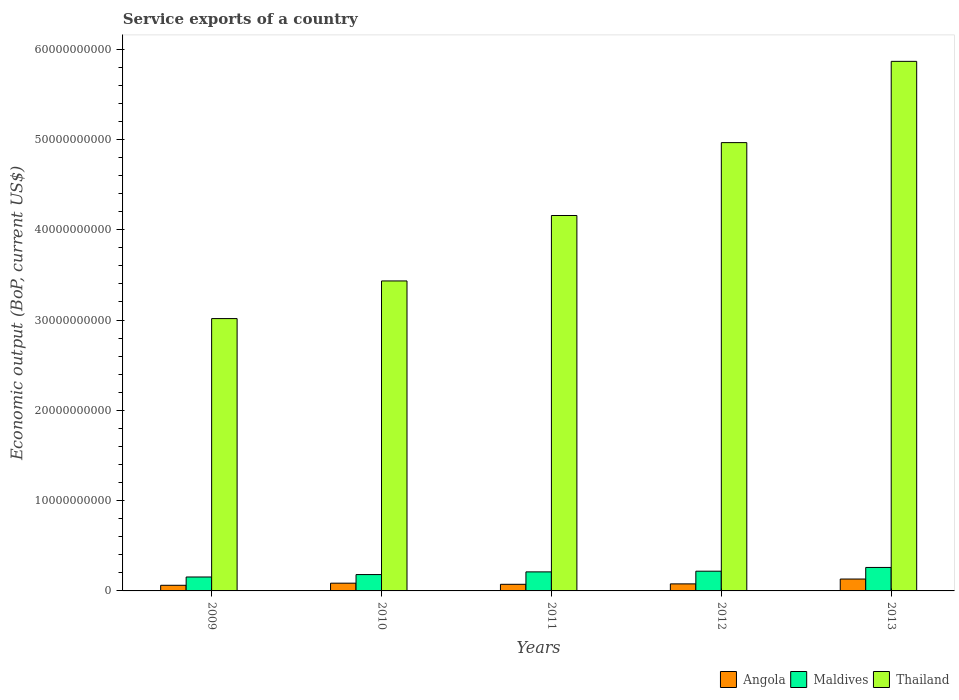How many bars are there on the 1st tick from the left?
Make the answer very short. 3. How many bars are there on the 4th tick from the right?
Offer a terse response. 3. In how many cases, is the number of bars for a given year not equal to the number of legend labels?
Your answer should be very brief. 0. What is the service exports in Angola in 2012?
Give a very brief answer. 7.80e+08. Across all years, what is the maximum service exports in Thailand?
Ensure brevity in your answer.  5.86e+1. Across all years, what is the minimum service exports in Maldives?
Provide a succinct answer. 1.54e+09. In which year was the service exports in Thailand minimum?
Your response must be concise. 2009. What is the total service exports in Maldives in the graph?
Keep it short and to the point. 1.02e+1. What is the difference between the service exports in Maldives in 2012 and that in 2013?
Offer a very short reply. -4.15e+08. What is the difference between the service exports in Maldives in 2010 and the service exports in Thailand in 2009?
Keep it short and to the point. -2.83e+1. What is the average service exports in Angola per year?
Ensure brevity in your answer.  8.62e+08. In the year 2013, what is the difference between the service exports in Maldives and service exports in Thailand?
Make the answer very short. -5.60e+1. What is the ratio of the service exports in Thailand in 2010 to that in 2011?
Offer a terse response. 0.83. What is the difference between the highest and the second highest service exports in Thailand?
Ensure brevity in your answer.  9.00e+09. What is the difference between the highest and the lowest service exports in Maldives?
Give a very brief answer. 1.06e+09. In how many years, is the service exports in Thailand greater than the average service exports in Thailand taken over all years?
Offer a very short reply. 2. What does the 1st bar from the left in 2011 represents?
Offer a very short reply. Angola. What does the 2nd bar from the right in 2009 represents?
Make the answer very short. Maldives. Is it the case that in every year, the sum of the service exports in Maldives and service exports in Thailand is greater than the service exports in Angola?
Your answer should be compact. Yes. How many bars are there?
Provide a succinct answer. 15. What is the difference between two consecutive major ticks on the Y-axis?
Your response must be concise. 1.00e+1. Does the graph contain any zero values?
Your response must be concise. No. What is the title of the graph?
Make the answer very short. Service exports of a country. Does "Nepal" appear as one of the legend labels in the graph?
Offer a terse response. No. What is the label or title of the X-axis?
Provide a succinct answer. Years. What is the label or title of the Y-axis?
Offer a terse response. Economic output (BoP, current US$). What is the Economic output (BoP, current US$) of Angola in 2009?
Provide a succinct answer. 6.23e+08. What is the Economic output (BoP, current US$) of Maldives in 2009?
Your answer should be very brief. 1.54e+09. What is the Economic output (BoP, current US$) in Thailand in 2009?
Provide a succinct answer. 3.02e+1. What is the Economic output (BoP, current US$) of Angola in 2010?
Your response must be concise. 8.57e+08. What is the Economic output (BoP, current US$) of Maldives in 2010?
Your response must be concise. 1.81e+09. What is the Economic output (BoP, current US$) of Thailand in 2010?
Your answer should be compact. 3.43e+1. What is the Economic output (BoP, current US$) of Angola in 2011?
Keep it short and to the point. 7.32e+08. What is the Economic output (BoP, current US$) of Maldives in 2011?
Give a very brief answer. 2.11e+09. What is the Economic output (BoP, current US$) in Thailand in 2011?
Ensure brevity in your answer.  4.16e+1. What is the Economic output (BoP, current US$) in Angola in 2012?
Your response must be concise. 7.80e+08. What is the Economic output (BoP, current US$) in Maldives in 2012?
Offer a very short reply. 2.18e+09. What is the Economic output (BoP, current US$) of Thailand in 2012?
Provide a short and direct response. 4.96e+1. What is the Economic output (BoP, current US$) of Angola in 2013?
Give a very brief answer. 1.32e+09. What is the Economic output (BoP, current US$) of Maldives in 2013?
Make the answer very short. 2.60e+09. What is the Economic output (BoP, current US$) in Thailand in 2013?
Your response must be concise. 5.86e+1. Across all years, what is the maximum Economic output (BoP, current US$) of Angola?
Give a very brief answer. 1.32e+09. Across all years, what is the maximum Economic output (BoP, current US$) of Maldives?
Keep it short and to the point. 2.60e+09. Across all years, what is the maximum Economic output (BoP, current US$) of Thailand?
Keep it short and to the point. 5.86e+1. Across all years, what is the minimum Economic output (BoP, current US$) of Angola?
Your answer should be compact. 6.23e+08. Across all years, what is the minimum Economic output (BoP, current US$) in Maldives?
Your answer should be very brief. 1.54e+09. Across all years, what is the minimum Economic output (BoP, current US$) in Thailand?
Offer a very short reply. 3.02e+1. What is the total Economic output (BoP, current US$) in Angola in the graph?
Your answer should be compact. 4.31e+09. What is the total Economic output (BoP, current US$) of Maldives in the graph?
Offer a very short reply. 1.02e+1. What is the total Economic output (BoP, current US$) of Thailand in the graph?
Provide a succinct answer. 2.14e+11. What is the difference between the Economic output (BoP, current US$) in Angola in 2009 and that in 2010?
Offer a terse response. -2.34e+08. What is the difference between the Economic output (BoP, current US$) in Maldives in 2009 and that in 2010?
Your answer should be compact. -2.67e+08. What is the difference between the Economic output (BoP, current US$) in Thailand in 2009 and that in 2010?
Offer a terse response. -4.17e+09. What is the difference between the Economic output (BoP, current US$) of Angola in 2009 and that in 2011?
Make the answer very short. -1.09e+08. What is the difference between the Economic output (BoP, current US$) of Maldives in 2009 and that in 2011?
Your answer should be very brief. -5.65e+08. What is the difference between the Economic output (BoP, current US$) in Thailand in 2009 and that in 2011?
Provide a succinct answer. -1.14e+1. What is the difference between the Economic output (BoP, current US$) in Angola in 2009 and that in 2012?
Your answer should be very brief. -1.57e+08. What is the difference between the Economic output (BoP, current US$) of Maldives in 2009 and that in 2012?
Keep it short and to the point. -6.41e+08. What is the difference between the Economic output (BoP, current US$) of Thailand in 2009 and that in 2012?
Ensure brevity in your answer.  -1.95e+1. What is the difference between the Economic output (BoP, current US$) in Angola in 2009 and that in 2013?
Give a very brief answer. -6.93e+08. What is the difference between the Economic output (BoP, current US$) of Maldives in 2009 and that in 2013?
Provide a succinct answer. -1.06e+09. What is the difference between the Economic output (BoP, current US$) in Thailand in 2009 and that in 2013?
Ensure brevity in your answer.  -2.85e+1. What is the difference between the Economic output (BoP, current US$) in Angola in 2010 and that in 2011?
Keep it short and to the point. 1.25e+08. What is the difference between the Economic output (BoP, current US$) of Maldives in 2010 and that in 2011?
Offer a very short reply. -2.99e+08. What is the difference between the Economic output (BoP, current US$) of Thailand in 2010 and that in 2011?
Ensure brevity in your answer.  -7.25e+09. What is the difference between the Economic output (BoP, current US$) of Angola in 2010 and that in 2012?
Provide a short and direct response. 7.69e+07. What is the difference between the Economic output (BoP, current US$) of Maldives in 2010 and that in 2012?
Offer a very short reply. -3.74e+08. What is the difference between the Economic output (BoP, current US$) in Thailand in 2010 and that in 2012?
Give a very brief answer. -1.53e+1. What is the difference between the Economic output (BoP, current US$) of Angola in 2010 and that in 2013?
Your answer should be compact. -4.59e+08. What is the difference between the Economic output (BoP, current US$) of Maldives in 2010 and that in 2013?
Offer a terse response. -7.89e+08. What is the difference between the Economic output (BoP, current US$) of Thailand in 2010 and that in 2013?
Provide a succinct answer. -2.43e+1. What is the difference between the Economic output (BoP, current US$) in Angola in 2011 and that in 2012?
Offer a terse response. -4.78e+07. What is the difference between the Economic output (BoP, current US$) in Maldives in 2011 and that in 2012?
Your response must be concise. -7.55e+07. What is the difference between the Economic output (BoP, current US$) of Thailand in 2011 and that in 2012?
Make the answer very short. -8.07e+09. What is the difference between the Economic output (BoP, current US$) in Angola in 2011 and that in 2013?
Offer a terse response. -5.83e+08. What is the difference between the Economic output (BoP, current US$) of Maldives in 2011 and that in 2013?
Ensure brevity in your answer.  -4.90e+08. What is the difference between the Economic output (BoP, current US$) in Thailand in 2011 and that in 2013?
Offer a terse response. -1.71e+1. What is the difference between the Economic output (BoP, current US$) of Angola in 2012 and that in 2013?
Provide a succinct answer. -5.36e+08. What is the difference between the Economic output (BoP, current US$) of Maldives in 2012 and that in 2013?
Your answer should be very brief. -4.15e+08. What is the difference between the Economic output (BoP, current US$) of Thailand in 2012 and that in 2013?
Provide a short and direct response. -9.00e+09. What is the difference between the Economic output (BoP, current US$) in Angola in 2009 and the Economic output (BoP, current US$) in Maldives in 2010?
Ensure brevity in your answer.  -1.19e+09. What is the difference between the Economic output (BoP, current US$) in Angola in 2009 and the Economic output (BoP, current US$) in Thailand in 2010?
Keep it short and to the point. -3.37e+1. What is the difference between the Economic output (BoP, current US$) in Maldives in 2009 and the Economic output (BoP, current US$) in Thailand in 2010?
Offer a terse response. -3.28e+1. What is the difference between the Economic output (BoP, current US$) in Angola in 2009 and the Economic output (BoP, current US$) in Maldives in 2011?
Keep it short and to the point. -1.49e+09. What is the difference between the Economic output (BoP, current US$) in Angola in 2009 and the Economic output (BoP, current US$) in Thailand in 2011?
Ensure brevity in your answer.  -4.09e+1. What is the difference between the Economic output (BoP, current US$) in Maldives in 2009 and the Economic output (BoP, current US$) in Thailand in 2011?
Your response must be concise. -4.00e+1. What is the difference between the Economic output (BoP, current US$) of Angola in 2009 and the Economic output (BoP, current US$) of Maldives in 2012?
Offer a terse response. -1.56e+09. What is the difference between the Economic output (BoP, current US$) in Angola in 2009 and the Economic output (BoP, current US$) in Thailand in 2012?
Give a very brief answer. -4.90e+1. What is the difference between the Economic output (BoP, current US$) of Maldives in 2009 and the Economic output (BoP, current US$) of Thailand in 2012?
Offer a terse response. -4.81e+1. What is the difference between the Economic output (BoP, current US$) in Angola in 2009 and the Economic output (BoP, current US$) in Maldives in 2013?
Provide a short and direct response. -1.98e+09. What is the difference between the Economic output (BoP, current US$) of Angola in 2009 and the Economic output (BoP, current US$) of Thailand in 2013?
Your response must be concise. -5.80e+1. What is the difference between the Economic output (BoP, current US$) of Maldives in 2009 and the Economic output (BoP, current US$) of Thailand in 2013?
Your answer should be very brief. -5.71e+1. What is the difference between the Economic output (BoP, current US$) in Angola in 2010 and the Economic output (BoP, current US$) in Maldives in 2011?
Make the answer very short. -1.25e+09. What is the difference between the Economic output (BoP, current US$) in Angola in 2010 and the Economic output (BoP, current US$) in Thailand in 2011?
Your answer should be compact. -4.07e+1. What is the difference between the Economic output (BoP, current US$) of Maldives in 2010 and the Economic output (BoP, current US$) of Thailand in 2011?
Keep it short and to the point. -3.98e+1. What is the difference between the Economic output (BoP, current US$) of Angola in 2010 and the Economic output (BoP, current US$) of Maldives in 2012?
Offer a very short reply. -1.33e+09. What is the difference between the Economic output (BoP, current US$) of Angola in 2010 and the Economic output (BoP, current US$) of Thailand in 2012?
Give a very brief answer. -4.88e+1. What is the difference between the Economic output (BoP, current US$) of Maldives in 2010 and the Economic output (BoP, current US$) of Thailand in 2012?
Your answer should be compact. -4.78e+1. What is the difference between the Economic output (BoP, current US$) of Angola in 2010 and the Economic output (BoP, current US$) of Maldives in 2013?
Provide a succinct answer. -1.74e+09. What is the difference between the Economic output (BoP, current US$) in Angola in 2010 and the Economic output (BoP, current US$) in Thailand in 2013?
Make the answer very short. -5.78e+1. What is the difference between the Economic output (BoP, current US$) in Maldives in 2010 and the Economic output (BoP, current US$) in Thailand in 2013?
Provide a short and direct response. -5.68e+1. What is the difference between the Economic output (BoP, current US$) in Angola in 2011 and the Economic output (BoP, current US$) in Maldives in 2012?
Provide a succinct answer. -1.45e+09. What is the difference between the Economic output (BoP, current US$) of Angola in 2011 and the Economic output (BoP, current US$) of Thailand in 2012?
Provide a short and direct response. -4.89e+1. What is the difference between the Economic output (BoP, current US$) of Maldives in 2011 and the Economic output (BoP, current US$) of Thailand in 2012?
Your response must be concise. -4.75e+1. What is the difference between the Economic output (BoP, current US$) of Angola in 2011 and the Economic output (BoP, current US$) of Maldives in 2013?
Keep it short and to the point. -1.87e+09. What is the difference between the Economic output (BoP, current US$) of Angola in 2011 and the Economic output (BoP, current US$) of Thailand in 2013?
Offer a terse response. -5.79e+1. What is the difference between the Economic output (BoP, current US$) in Maldives in 2011 and the Economic output (BoP, current US$) in Thailand in 2013?
Ensure brevity in your answer.  -5.65e+1. What is the difference between the Economic output (BoP, current US$) in Angola in 2012 and the Economic output (BoP, current US$) in Maldives in 2013?
Offer a terse response. -1.82e+09. What is the difference between the Economic output (BoP, current US$) in Angola in 2012 and the Economic output (BoP, current US$) in Thailand in 2013?
Keep it short and to the point. -5.79e+1. What is the difference between the Economic output (BoP, current US$) in Maldives in 2012 and the Economic output (BoP, current US$) in Thailand in 2013?
Keep it short and to the point. -5.65e+1. What is the average Economic output (BoP, current US$) in Angola per year?
Give a very brief answer. 8.62e+08. What is the average Economic output (BoP, current US$) in Maldives per year?
Your answer should be compact. 2.05e+09. What is the average Economic output (BoP, current US$) of Thailand per year?
Your answer should be compact. 4.29e+1. In the year 2009, what is the difference between the Economic output (BoP, current US$) in Angola and Economic output (BoP, current US$) in Maldives?
Make the answer very short. -9.20e+08. In the year 2009, what is the difference between the Economic output (BoP, current US$) of Angola and Economic output (BoP, current US$) of Thailand?
Ensure brevity in your answer.  -2.95e+1. In the year 2009, what is the difference between the Economic output (BoP, current US$) in Maldives and Economic output (BoP, current US$) in Thailand?
Your answer should be very brief. -2.86e+1. In the year 2010, what is the difference between the Economic output (BoP, current US$) of Angola and Economic output (BoP, current US$) of Maldives?
Make the answer very short. -9.53e+08. In the year 2010, what is the difference between the Economic output (BoP, current US$) in Angola and Economic output (BoP, current US$) in Thailand?
Give a very brief answer. -3.35e+1. In the year 2010, what is the difference between the Economic output (BoP, current US$) in Maldives and Economic output (BoP, current US$) in Thailand?
Your answer should be very brief. -3.25e+1. In the year 2011, what is the difference between the Economic output (BoP, current US$) of Angola and Economic output (BoP, current US$) of Maldives?
Keep it short and to the point. -1.38e+09. In the year 2011, what is the difference between the Economic output (BoP, current US$) in Angola and Economic output (BoP, current US$) in Thailand?
Ensure brevity in your answer.  -4.08e+1. In the year 2011, what is the difference between the Economic output (BoP, current US$) of Maldives and Economic output (BoP, current US$) of Thailand?
Make the answer very short. -3.95e+1. In the year 2012, what is the difference between the Economic output (BoP, current US$) in Angola and Economic output (BoP, current US$) in Maldives?
Offer a very short reply. -1.40e+09. In the year 2012, what is the difference between the Economic output (BoP, current US$) of Angola and Economic output (BoP, current US$) of Thailand?
Provide a succinct answer. -4.89e+1. In the year 2012, what is the difference between the Economic output (BoP, current US$) in Maldives and Economic output (BoP, current US$) in Thailand?
Provide a succinct answer. -4.75e+1. In the year 2013, what is the difference between the Economic output (BoP, current US$) in Angola and Economic output (BoP, current US$) in Maldives?
Offer a very short reply. -1.28e+09. In the year 2013, what is the difference between the Economic output (BoP, current US$) of Angola and Economic output (BoP, current US$) of Thailand?
Your response must be concise. -5.73e+1. In the year 2013, what is the difference between the Economic output (BoP, current US$) in Maldives and Economic output (BoP, current US$) in Thailand?
Your response must be concise. -5.60e+1. What is the ratio of the Economic output (BoP, current US$) of Angola in 2009 to that in 2010?
Offer a terse response. 0.73. What is the ratio of the Economic output (BoP, current US$) in Maldives in 2009 to that in 2010?
Offer a terse response. 0.85. What is the ratio of the Economic output (BoP, current US$) in Thailand in 2009 to that in 2010?
Your answer should be very brief. 0.88. What is the ratio of the Economic output (BoP, current US$) in Angola in 2009 to that in 2011?
Keep it short and to the point. 0.85. What is the ratio of the Economic output (BoP, current US$) of Maldives in 2009 to that in 2011?
Your answer should be compact. 0.73. What is the ratio of the Economic output (BoP, current US$) in Thailand in 2009 to that in 2011?
Keep it short and to the point. 0.73. What is the ratio of the Economic output (BoP, current US$) in Angola in 2009 to that in 2012?
Ensure brevity in your answer.  0.8. What is the ratio of the Economic output (BoP, current US$) of Maldives in 2009 to that in 2012?
Your answer should be very brief. 0.71. What is the ratio of the Economic output (BoP, current US$) of Thailand in 2009 to that in 2012?
Make the answer very short. 0.61. What is the ratio of the Economic output (BoP, current US$) of Angola in 2009 to that in 2013?
Your answer should be very brief. 0.47. What is the ratio of the Economic output (BoP, current US$) of Maldives in 2009 to that in 2013?
Provide a short and direct response. 0.59. What is the ratio of the Economic output (BoP, current US$) in Thailand in 2009 to that in 2013?
Your response must be concise. 0.51. What is the ratio of the Economic output (BoP, current US$) of Angola in 2010 to that in 2011?
Give a very brief answer. 1.17. What is the ratio of the Economic output (BoP, current US$) in Maldives in 2010 to that in 2011?
Keep it short and to the point. 0.86. What is the ratio of the Economic output (BoP, current US$) in Thailand in 2010 to that in 2011?
Provide a succinct answer. 0.83. What is the ratio of the Economic output (BoP, current US$) of Angola in 2010 to that in 2012?
Ensure brevity in your answer.  1.1. What is the ratio of the Economic output (BoP, current US$) in Maldives in 2010 to that in 2012?
Offer a very short reply. 0.83. What is the ratio of the Economic output (BoP, current US$) of Thailand in 2010 to that in 2012?
Your answer should be very brief. 0.69. What is the ratio of the Economic output (BoP, current US$) of Angola in 2010 to that in 2013?
Make the answer very short. 0.65. What is the ratio of the Economic output (BoP, current US$) in Maldives in 2010 to that in 2013?
Make the answer very short. 0.7. What is the ratio of the Economic output (BoP, current US$) in Thailand in 2010 to that in 2013?
Your answer should be compact. 0.59. What is the ratio of the Economic output (BoP, current US$) of Angola in 2011 to that in 2012?
Offer a very short reply. 0.94. What is the ratio of the Economic output (BoP, current US$) of Maldives in 2011 to that in 2012?
Provide a short and direct response. 0.97. What is the ratio of the Economic output (BoP, current US$) of Thailand in 2011 to that in 2012?
Ensure brevity in your answer.  0.84. What is the ratio of the Economic output (BoP, current US$) in Angola in 2011 to that in 2013?
Offer a terse response. 0.56. What is the ratio of the Economic output (BoP, current US$) in Maldives in 2011 to that in 2013?
Your answer should be very brief. 0.81. What is the ratio of the Economic output (BoP, current US$) of Thailand in 2011 to that in 2013?
Keep it short and to the point. 0.71. What is the ratio of the Economic output (BoP, current US$) of Angola in 2012 to that in 2013?
Keep it short and to the point. 0.59. What is the ratio of the Economic output (BoP, current US$) in Maldives in 2012 to that in 2013?
Give a very brief answer. 0.84. What is the ratio of the Economic output (BoP, current US$) of Thailand in 2012 to that in 2013?
Provide a short and direct response. 0.85. What is the difference between the highest and the second highest Economic output (BoP, current US$) in Angola?
Provide a succinct answer. 4.59e+08. What is the difference between the highest and the second highest Economic output (BoP, current US$) in Maldives?
Your answer should be very brief. 4.15e+08. What is the difference between the highest and the second highest Economic output (BoP, current US$) in Thailand?
Your response must be concise. 9.00e+09. What is the difference between the highest and the lowest Economic output (BoP, current US$) of Angola?
Keep it short and to the point. 6.93e+08. What is the difference between the highest and the lowest Economic output (BoP, current US$) in Maldives?
Your answer should be very brief. 1.06e+09. What is the difference between the highest and the lowest Economic output (BoP, current US$) of Thailand?
Give a very brief answer. 2.85e+1. 